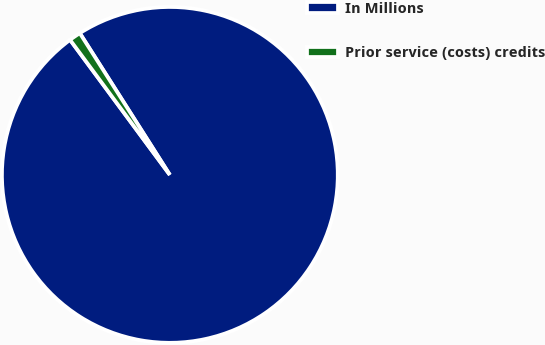Convert chart to OTSL. <chart><loc_0><loc_0><loc_500><loc_500><pie_chart><fcel>In Millions<fcel>Prior service (costs) credits<nl><fcel>98.88%<fcel>1.12%<nl></chart> 